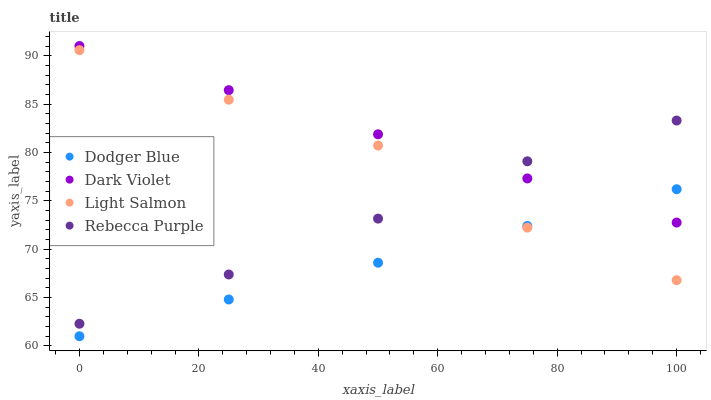Does Dodger Blue have the minimum area under the curve?
Answer yes or no. Yes. Does Dark Violet have the maximum area under the curve?
Answer yes or no. Yes. Does Rebecca Purple have the minimum area under the curve?
Answer yes or no. No. Does Rebecca Purple have the maximum area under the curve?
Answer yes or no. No. Is Dodger Blue the smoothest?
Answer yes or no. Yes. Is Light Salmon the roughest?
Answer yes or no. Yes. Is Rebecca Purple the smoothest?
Answer yes or no. No. Is Rebecca Purple the roughest?
Answer yes or no. No. Does Dodger Blue have the lowest value?
Answer yes or no. Yes. Does Rebecca Purple have the lowest value?
Answer yes or no. No. Does Dark Violet have the highest value?
Answer yes or no. Yes. Does Rebecca Purple have the highest value?
Answer yes or no. No. Is Dodger Blue less than Rebecca Purple?
Answer yes or no. Yes. Is Dark Violet greater than Light Salmon?
Answer yes or no. Yes. Does Light Salmon intersect Rebecca Purple?
Answer yes or no. Yes. Is Light Salmon less than Rebecca Purple?
Answer yes or no. No. Is Light Salmon greater than Rebecca Purple?
Answer yes or no. No. Does Dodger Blue intersect Rebecca Purple?
Answer yes or no. No. 